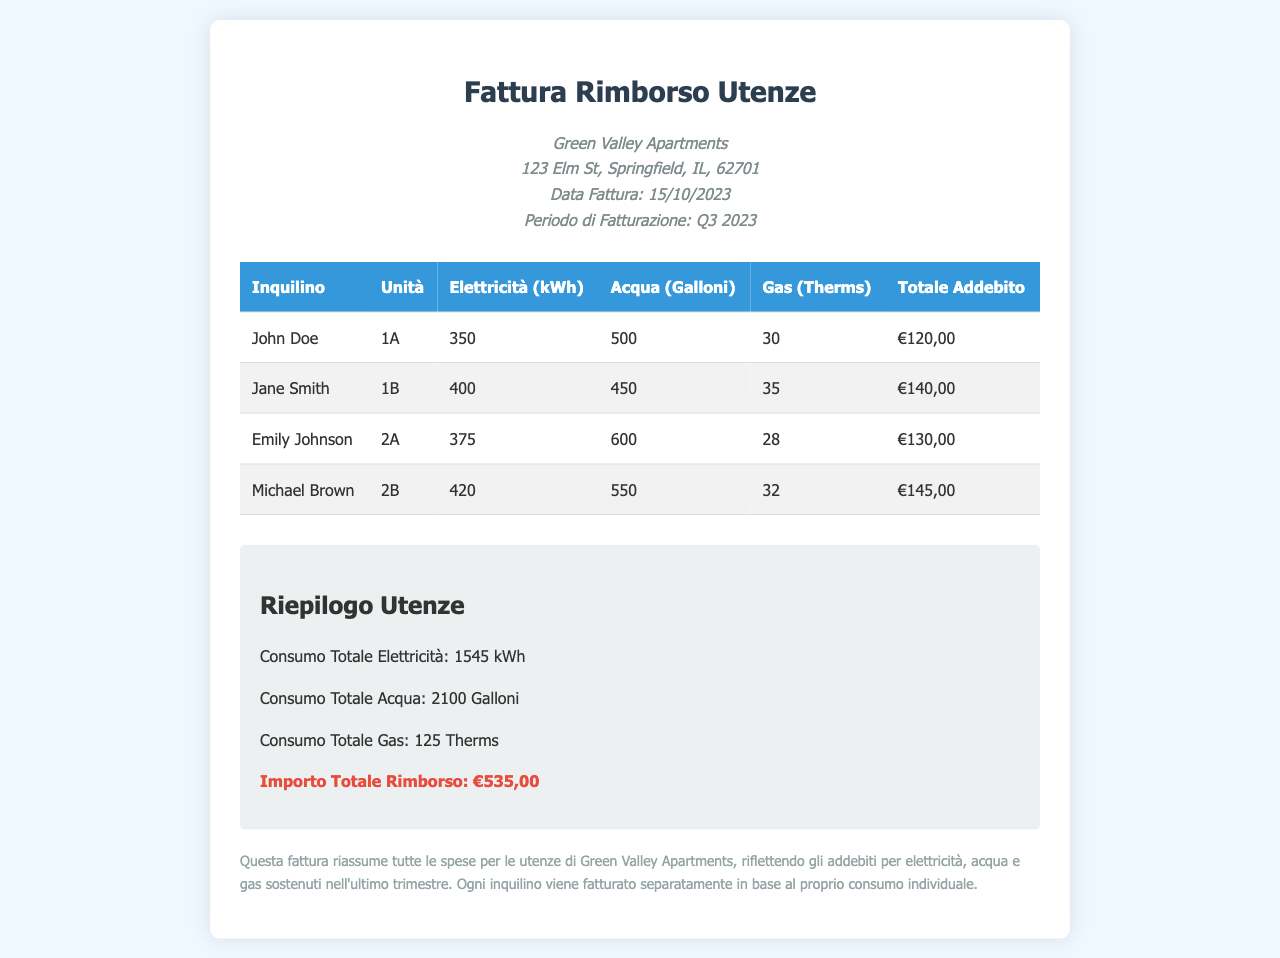What is the property name? The property name is mentioned at the top of the invoice, indicating where the utility reimbursement applies.
Answer: Green Valley Apartments What is the total reimbursement amount? The total reimbursement amount is summarized at the bottom of the invoice.
Answer: €535,00 How many gallons of water did Emily Johnson use? The document lists the water usage for each tenant, including Emily Johnson's.
Answer: 600 Galloni What is the electricity consumption for John Doe's unit? The electricity consumption for each tenant is specified in the table provided in the document.
Answer: 350 kWh When was the invoice issued? The date of the invoice is presented prominently in the header section.
Answer: 15/10/2023 How many therms of gas did Michael Brown use? The document details the gas consumption for each tenant, including Michael Brown's.
Answer: 32 Therms What is the billing period for this invoice? The billing period is noted in the header and indicates the timeframe for charges.
Answer: Q3 2023 Who has the highest total charge? The total charge for each tenant allows comparison to identify who incurred the highest charge.
Answer: Michael Brown What is the total electricity consumption across all units? The document provides a summary of total electricity usage at the end of the section under "Riepilogo Utenze."
Answer: 1545 kWh 